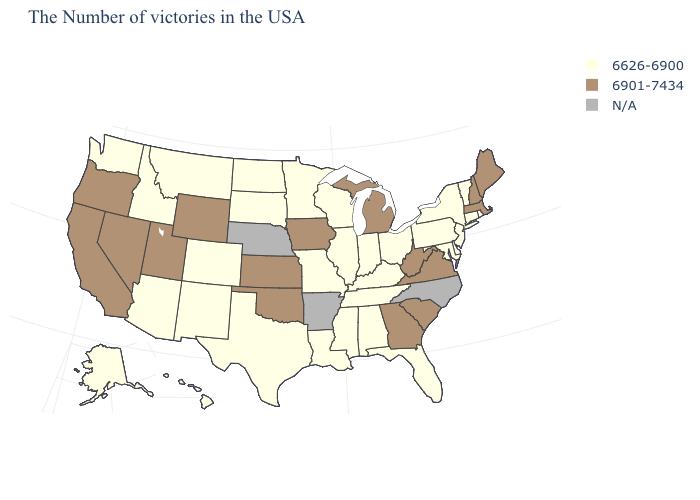Is the legend a continuous bar?
Write a very short answer. No. Name the states that have a value in the range 6626-6900?
Concise answer only. Rhode Island, Vermont, Connecticut, New York, New Jersey, Delaware, Maryland, Pennsylvania, Ohio, Florida, Kentucky, Indiana, Alabama, Tennessee, Wisconsin, Illinois, Mississippi, Louisiana, Missouri, Minnesota, Texas, South Dakota, North Dakota, Colorado, New Mexico, Montana, Arizona, Idaho, Washington, Alaska, Hawaii. Name the states that have a value in the range 6626-6900?
Be succinct. Rhode Island, Vermont, Connecticut, New York, New Jersey, Delaware, Maryland, Pennsylvania, Ohio, Florida, Kentucky, Indiana, Alabama, Tennessee, Wisconsin, Illinois, Mississippi, Louisiana, Missouri, Minnesota, Texas, South Dakota, North Dakota, Colorado, New Mexico, Montana, Arizona, Idaho, Washington, Alaska, Hawaii. What is the lowest value in the USA?
Write a very short answer. 6626-6900. Name the states that have a value in the range N/A?
Answer briefly. North Carolina, Arkansas, Nebraska. What is the value of Arkansas?
Give a very brief answer. N/A. Does Missouri have the highest value in the USA?
Quick response, please. No. What is the lowest value in states that border Louisiana?
Concise answer only. 6626-6900. What is the highest value in the MidWest ?
Write a very short answer. 6901-7434. Among the states that border Maryland , which have the lowest value?
Concise answer only. Delaware, Pennsylvania. Which states hav the highest value in the MidWest?
Concise answer only. Michigan, Iowa, Kansas. 